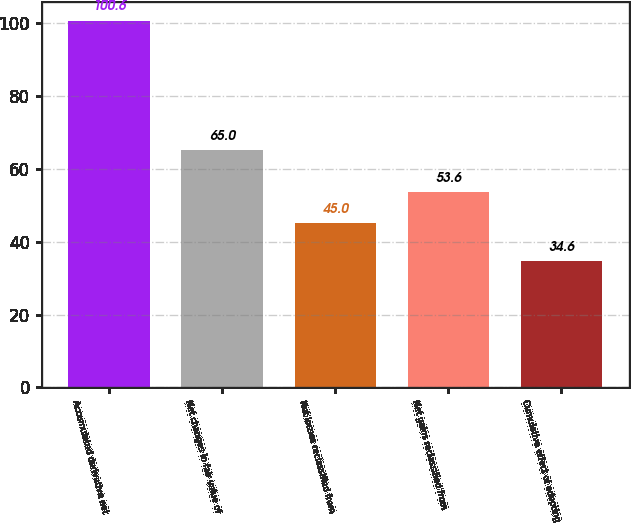Convert chart. <chart><loc_0><loc_0><loc_500><loc_500><bar_chart><fcel>Accumulated derivative net<fcel>Net changes in fair value of<fcel>Net losses reclassified from<fcel>Net gains reclassified from<fcel>Cumulative effect of adopting<nl><fcel>100.6<fcel>65<fcel>45<fcel>53.6<fcel>34.6<nl></chart> 